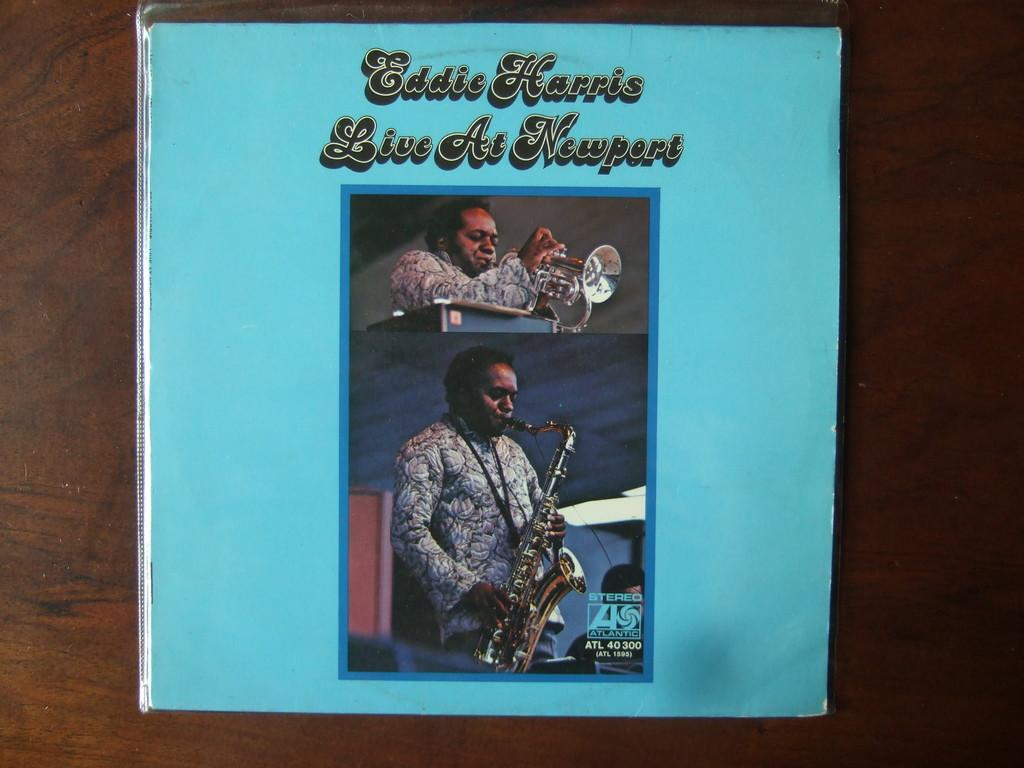Provide a one-sentence caption for the provided image. A brochure of Eddie Harris when he was performing at Newport. 